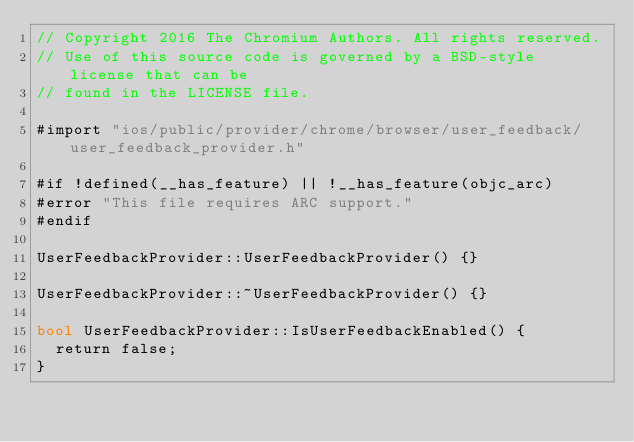<code> <loc_0><loc_0><loc_500><loc_500><_ObjectiveC_>// Copyright 2016 The Chromium Authors. All rights reserved.
// Use of this source code is governed by a BSD-style license that can be
// found in the LICENSE file.

#import "ios/public/provider/chrome/browser/user_feedback/user_feedback_provider.h"

#if !defined(__has_feature) || !__has_feature(objc_arc)
#error "This file requires ARC support."
#endif

UserFeedbackProvider::UserFeedbackProvider() {}

UserFeedbackProvider::~UserFeedbackProvider() {}

bool UserFeedbackProvider::IsUserFeedbackEnabled() {
  return false;
}
</code> 